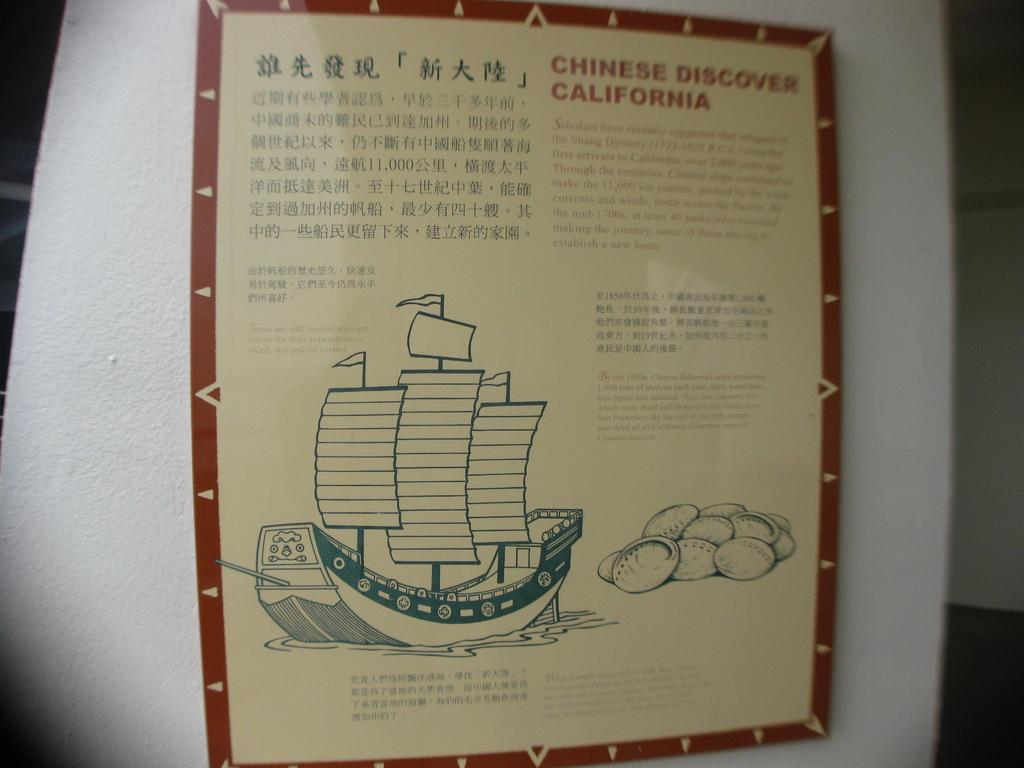<image>
Provide a brief description of the given image. A museum board with the title 'Chinese Discover California.' 